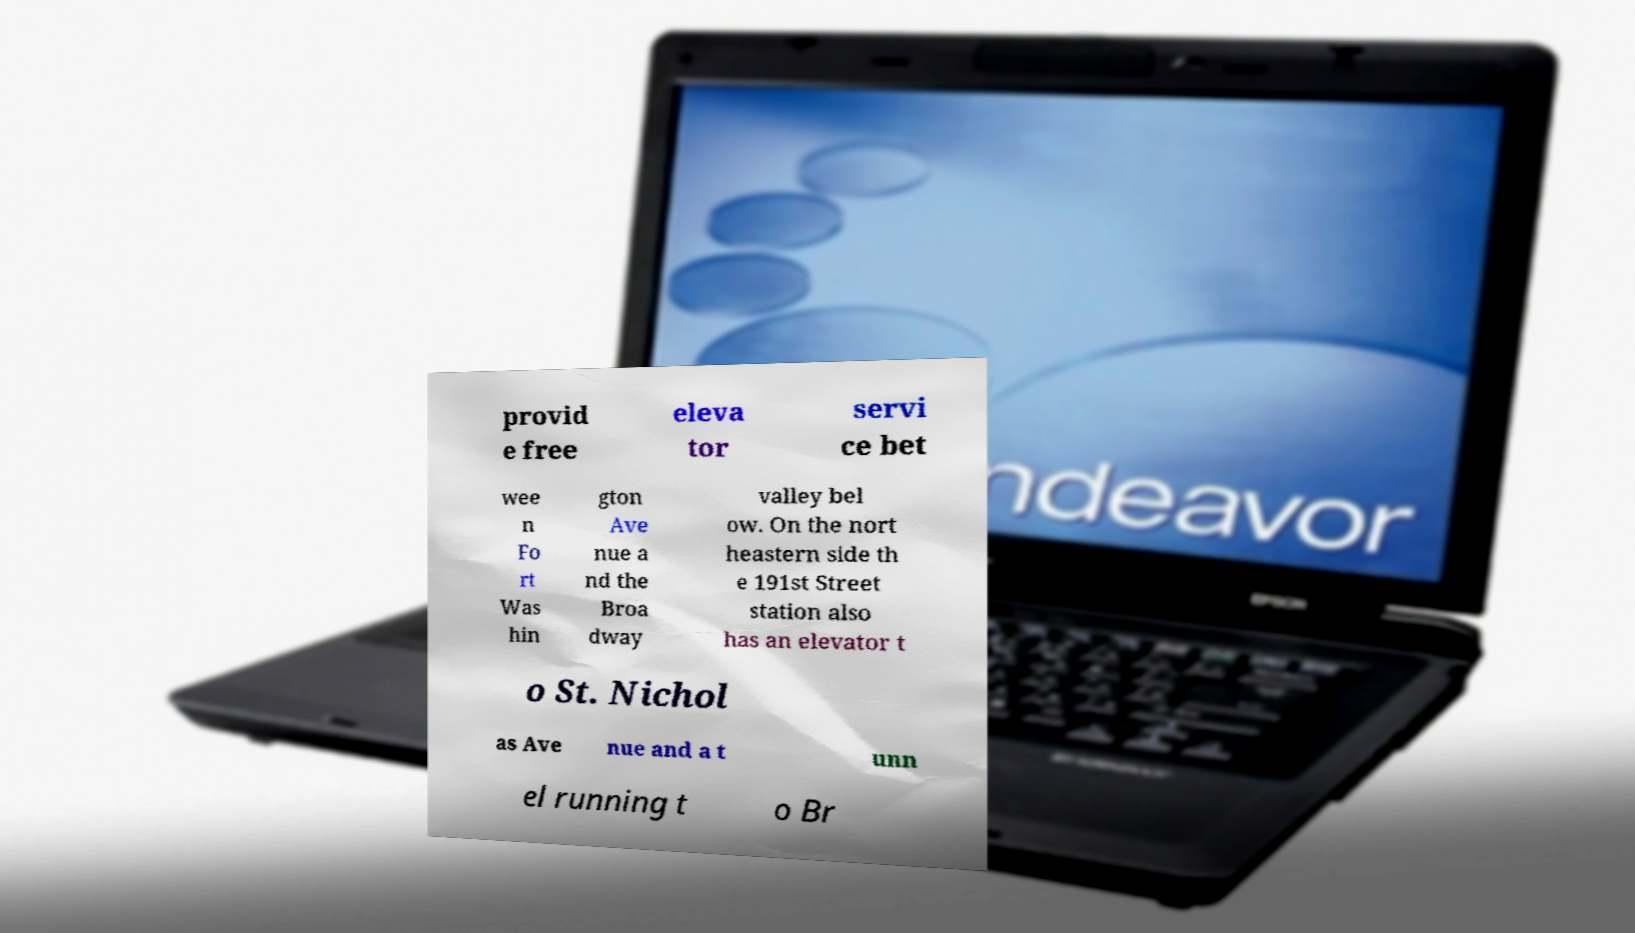For documentation purposes, I need the text within this image transcribed. Could you provide that? provid e free eleva tor servi ce bet wee n Fo rt Was hin gton Ave nue a nd the Broa dway valley bel ow. On the nort heastern side th e 191st Street station also has an elevator t o St. Nichol as Ave nue and a t unn el running t o Br 